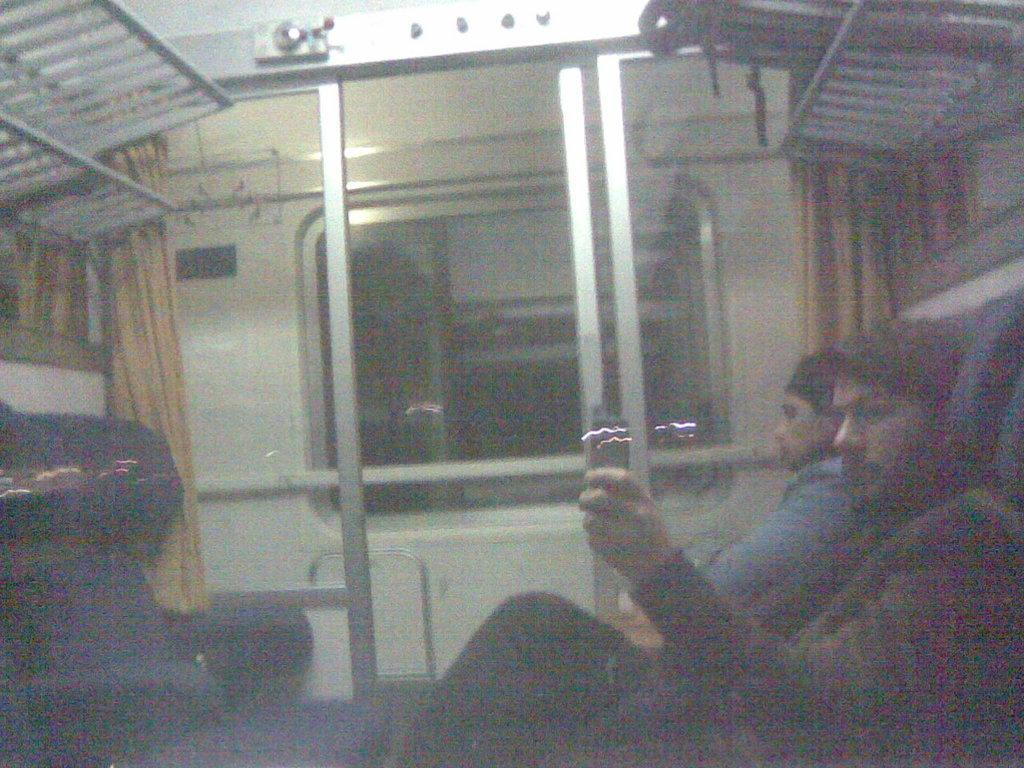What can be seen on the right side of the image? There are bags, persons, and a curtain on the right side of the image. What is located on the left side of the image? There are chairs, a curtain, and a grill on the left side of the image. Can you describe the background of the image? There is a window visible in the background of the image. What type of gold jewelry is being worn by the persons on the right side of the image? There is no mention of gold jewelry or any jewelry in the image. How does the low-quality image affect the visibility of the window in the background? The provided facts do not mention the quality of the image, so it is not possible to determine how it might affect the visibility of the window. 